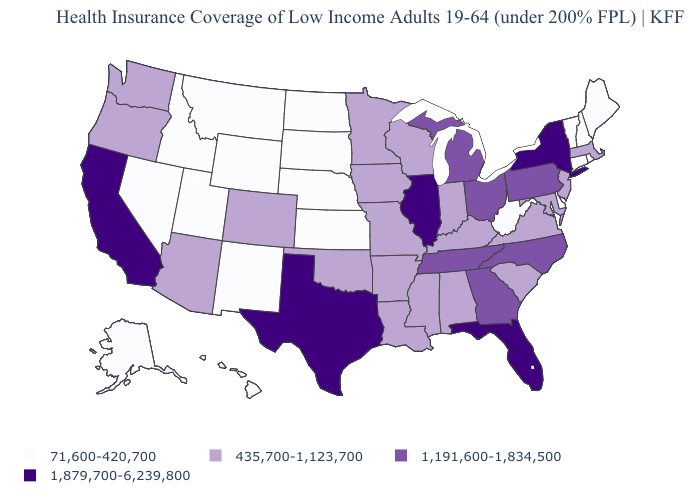What is the highest value in the USA?
Write a very short answer. 1,879,700-6,239,800. Name the states that have a value in the range 71,600-420,700?
Give a very brief answer. Alaska, Connecticut, Delaware, Hawaii, Idaho, Kansas, Maine, Montana, Nebraska, Nevada, New Hampshire, New Mexico, North Dakota, Rhode Island, South Dakota, Utah, Vermont, West Virginia, Wyoming. What is the lowest value in states that border Oklahoma?
Be succinct. 71,600-420,700. How many symbols are there in the legend?
Give a very brief answer. 4. Which states hav the highest value in the South?
Give a very brief answer. Florida, Texas. Name the states that have a value in the range 71,600-420,700?
Keep it brief. Alaska, Connecticut, Delaware, Hawaii, Idaho, Kansas, Maine, Montana, Nebraska, Nevada, New Hampshire, New Mexico, North Dakota, Rhode Island, South Dakota, Utah, Vermont, West Virginia, Wyoming. Name the states that have a value in the range 71,600-420,700?
Be succinct. Alaska, Connecticut, Delaware, Hawaii, Idaho, Kansas, Maine, Montana, Nebraska, Nevada, New Hampshire, New Mexico, North Dakota, Rhode Island, South Dakota, Utah, Vermont, West Virginia, Wyoming. Name the states that have a value in the range 1,879,700-6,239,800?
Keep it brief. California, Florida, Illinois, New York, Texas. Among the states that border North Dakota , which have the highest value?
Write a very short answer. Minnesota. Does the first symbol in the legend represent the smallest category?
Be succinct. Yes. Among the states that border Nevada , does Oregon have the highest value?
Give a very brief answer. No. What is the value of Rhode Island?
Keep it brief. 71,600-420,700. Among the states that border Wyoming , does Colorado have the highest value?
Keep it brief. Yes. What is the value of Michigan?
Answer briefly. 1,191,600-1,834,500. 